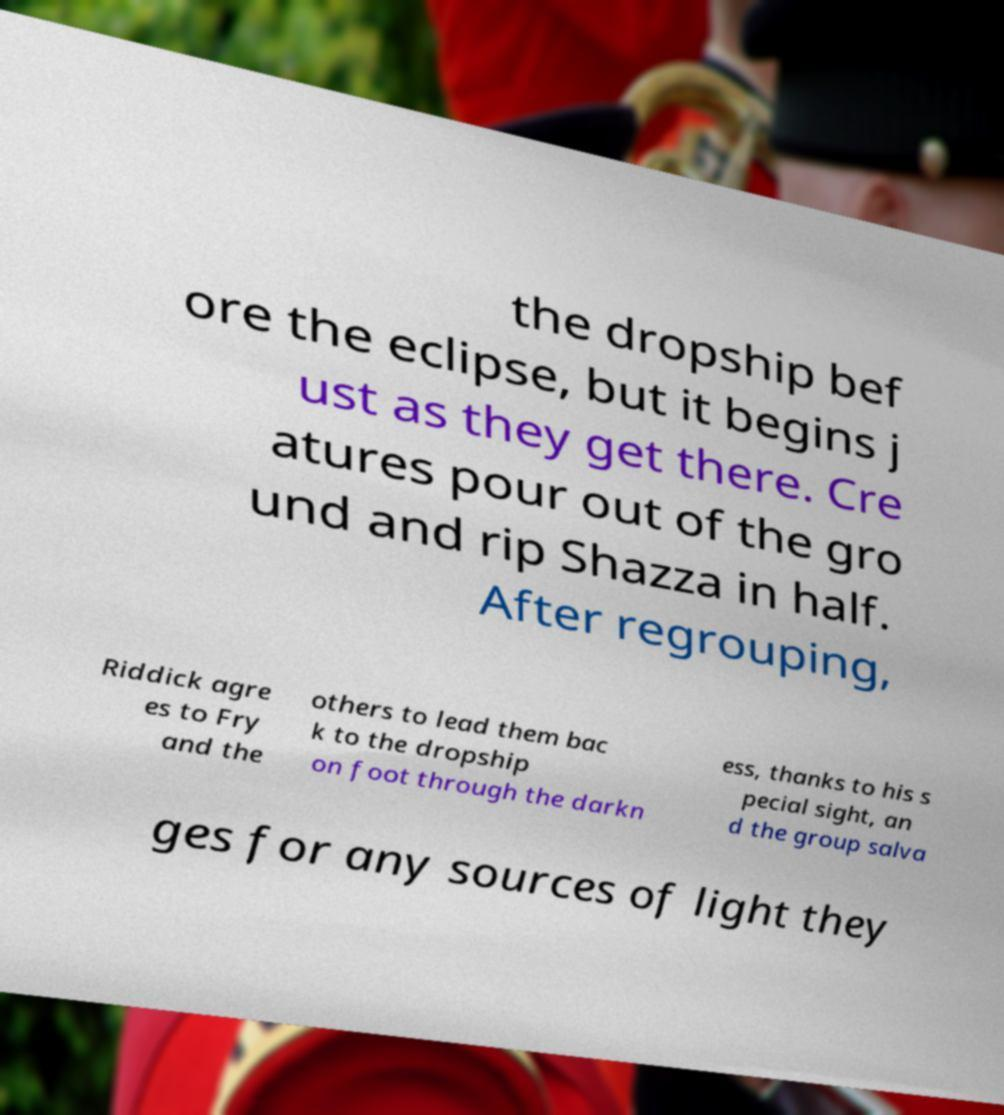Could you assist in decoding the text presented in this image and type it out clearly? the dropship bef ore the eclipse, but it begins j ust as they get there. Cre atures pour out of the gro und and rip Shazza in half. After regrouping, Riddick agre es to Fry and the others to lead them bac k to the dropship on foot through the darkn ess, thanks to his s pecial sight, an d the group salva ges for any sources of light they 